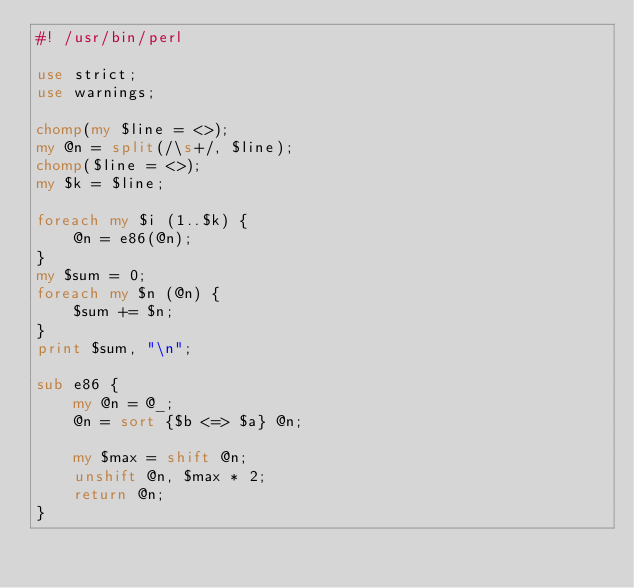Convert code to text. <code><loc_0><loc_0><loc_500><loc_500><_Perl_>#! /usr/bin/perl

use strict;
use warnings;

chomp(my $line = <>);
my @n = split(/\s+/, $line);
chomp($line = <>);
my $k = $line;

foreach my $i (1..$k) {
    @n = e86(@n);
}
my $sum = 0;
foreach my $n (@n) {
    $sum += $n;
}
print $sum, "\n";

sub e86 {
    my @n = @_;
    @n = sort {$b <=> $a} @n;

    my $max = shift @n;
    unshift @n, $max * 2;
    return @n;
}
</code> 